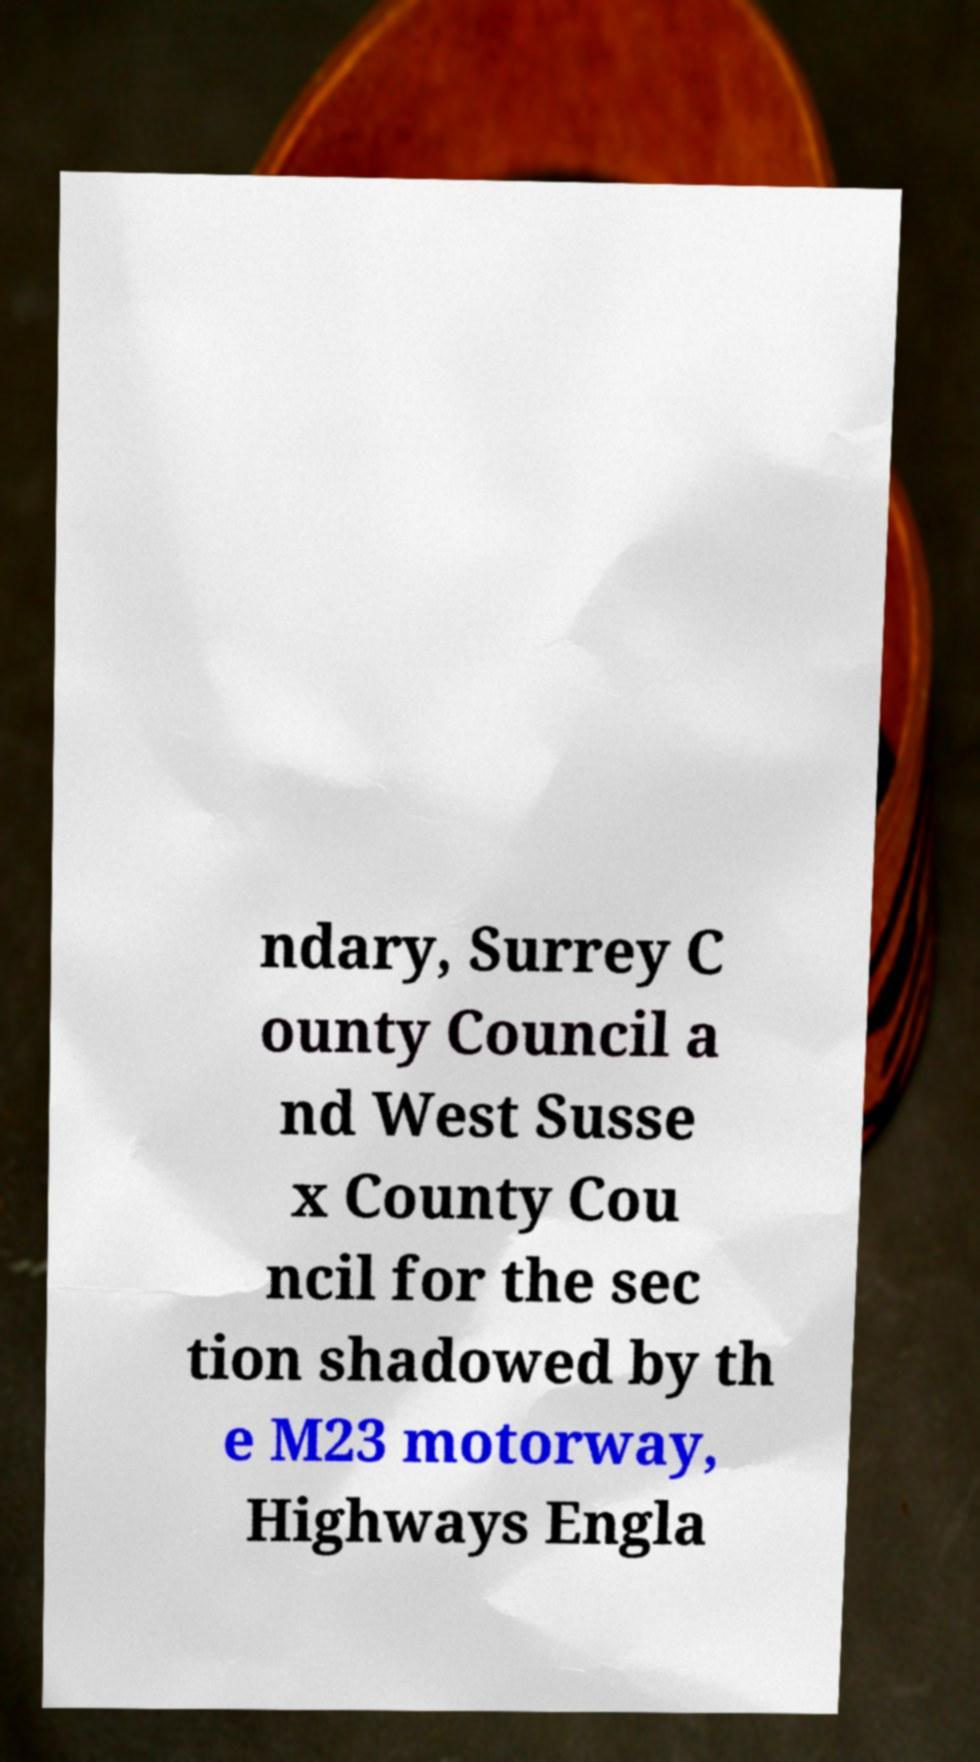Please read and relay the text visible in this image. What does it say? ndary, Surrey C ounty Council a nd West Susse x County Cou ncil for the sec tion shadowed by th e M23 motorway, Highways Engla 